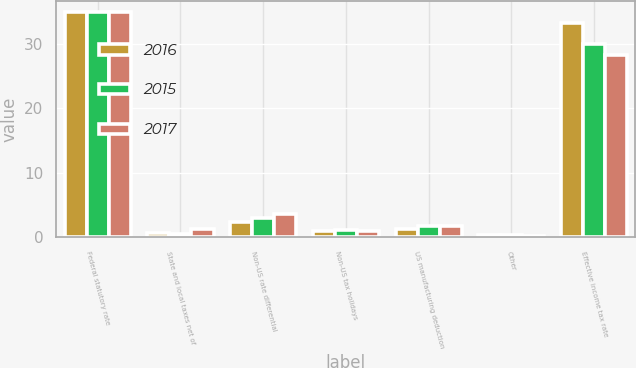Convert chart to OTSL. <chart><loc_0><loc_0><loc_500><loc_500><stacked_bar_chart><ecel><fcel>Federal statutory rate<fcel>State and local taxes net of<fcel>Non-US rate differential<fcel>Non-US tax holidays<fcel>US manufacturing deduction<fcel>Other<fcel>Effective income tax rate<nl><fcel>2016<fcel>35<fcel>0.7<fcel>2.4<fcel>0.9<fcel>1.2<fcel>0.3<fcel>33.3<nl><fcel>2015<fcel>35<fcel>0.5<fcel>2.9<fcel>1.1<fcel>1.8<fcel>0.4<fcel>30.1<nl><fcel>2017<fcel>35<fcel>1.2<fcel>3.6<fcel>1<fcel>1.7<fcel>0.2<fcel>28.3<nl></chart> 